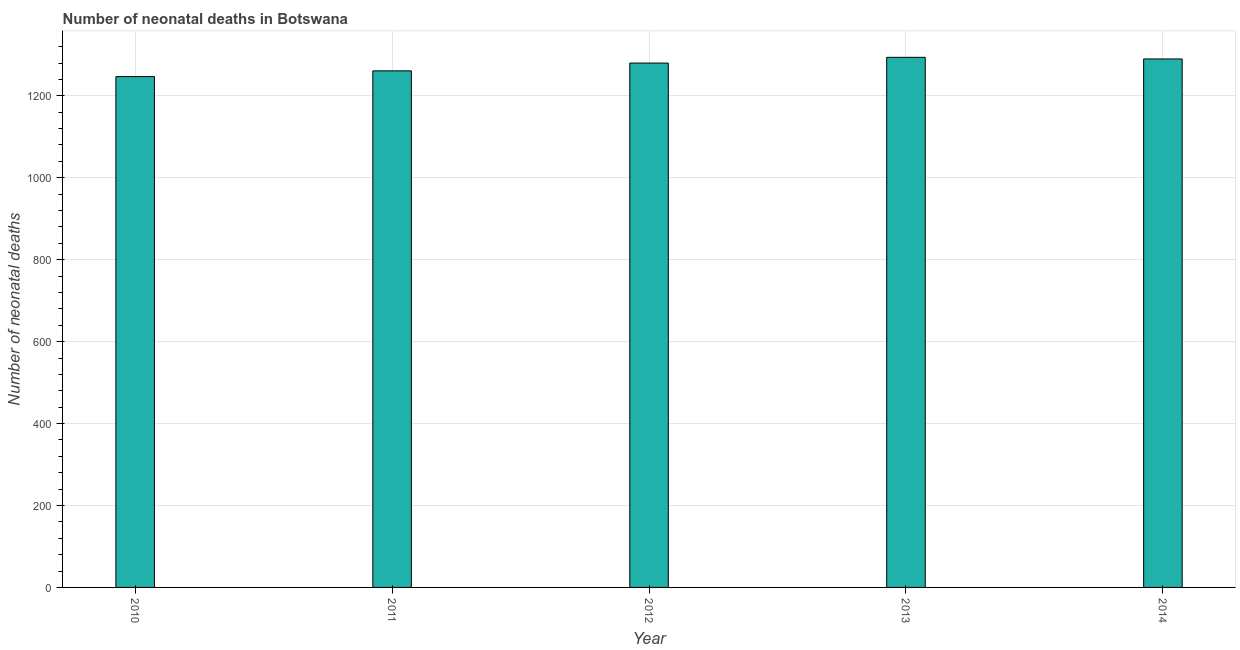What is the title of the graph?
Your answer should be compact. Number of neonatal deaths in Botswana. What is the label or title of the Y-axis?
Offer a very short reply. Number of neonatal deaths. What is the number of neonatal deaths in 2013?
Your answer should be very brief. 1294. Across all years, what is the maximum number of neonatal deaths?
Make the answer very short. 1294. Across all years, what is the minimum number of neonatal deaths?
Provide a succinct answer. 1247. In which year was the number of neonatal deaths maximum?
Give a very brief answer. 2013. What is the sum of the number of neonatal deaths?
Your response must be concise. 6372. What is the difference between the number of neonatal deaths in 2011 and 2014?
Give a very brief answer. -29. What is the average number of neonatal deaths per year?
Your response must be concise. 1274. What is the median number of neonatal deaths?
Keep it short and to the point. 1280. Do a majority of the years between 2014 and 2013 (inclusive) have number of neonatal deaths greater than 1240 ?
Your answer should be very brief. No. What is the ratio of the number of neonatal deaths in 2013 to that in 2014?
Offer a terse response. 1. Is the number of neonatal deaths in 2010 less than that in 2011?
Ensure brevity in your answer.  Yes. Is the difference between the number of neonatal deaths in 2012 and 2013 greater than the difference between any two years?
Make the answer very short. No. What is the difference between the highest and the second highest number of neonatal deaths?
Make the answer very short. 4. Is the sum of the number of neonatal deaths in 2012 and 2014 greater than the maximum number of neonatal deaths across all years?
Offer a terse response. Yes. What is the difference between the highest and the lowest number of neonatal deaths?
Provide a short and direct response. 47. Are all the bars in the graph horizontal?
Offer a terse response. No. How many years are there in the graph?
Offer a terse response. 5. Are the values on the major ticks of Y-axis written in scientific E-notation?
Offer a terse response. No. What is the Number of neonatal deaths in 2010?
Offer a very short reply. 1247. What is the Number of neonatal deaths of 2011?
Offer a very short reply. 1261. What is the Number of neonatal deaths in 2012?
Your response must be concise. 1280. What is the Number of neonatal deaths of 2013?
Your response must be concise. 1294. What is the Number of neonatal deaths in 2014?
Give a very brief answer. 1290. What is the difference between the Number of neonatal deaths in 2010 and 2012?
Keep it short and to the point. -33. What is the difference between the Number of neonatal deaths in 2010 and 2013?
Provide a short and direct response. -47. What is the difference between the Number of neonatal deaths in 2010 and 2014?
Offer a terse response. -43. What is the difference between the Number of neonatal deaths in 2011 and 2012?
Provide a succinct answer. -19. What is the difference between the Number of neonatal deaths in 2011 and 2013?
Your response must be concise. -33. What is the difference between the Number of neonatal deaths in 2011 and 2014?
Your response must be concise. -29. What is the difference between the Number of neonatal deaths in 2012 and 2013?
Give a very brief answer. -14. What is the difference between the Number of neonatal deaths in 2012 and 2014?
Provide a short and direct response. -10. What is the difference between the Number of neonatal deaths in 2013 and 2014?
Offer a very short reply. 4. What is the ratio of the Number of neonatal deaths in 2010 to that in 2013?
Offer a terse response. 0.96. What is the ratio of the Number of neonatal deaths in 2010 to that in 2014?
Keep it short and to the point. 0.97. What is the ratio of the Number of neonatal deaths in 2011 to that in 2012?
Your answer should be very brief. 0.98. What is the ratio of the Number of neonatal deaths in 2011 to that in 2013?
Ensure brevity in your answer.  0.97. What is the ratio of the Number of neonatal deaths in 2012 to that in 2013?
Ensure brevity in your answer.  0.99. What is the ratio of the Number of neonatal deaths in 2013 to that in 2014?
Ensure brevity in your answer.  1. 